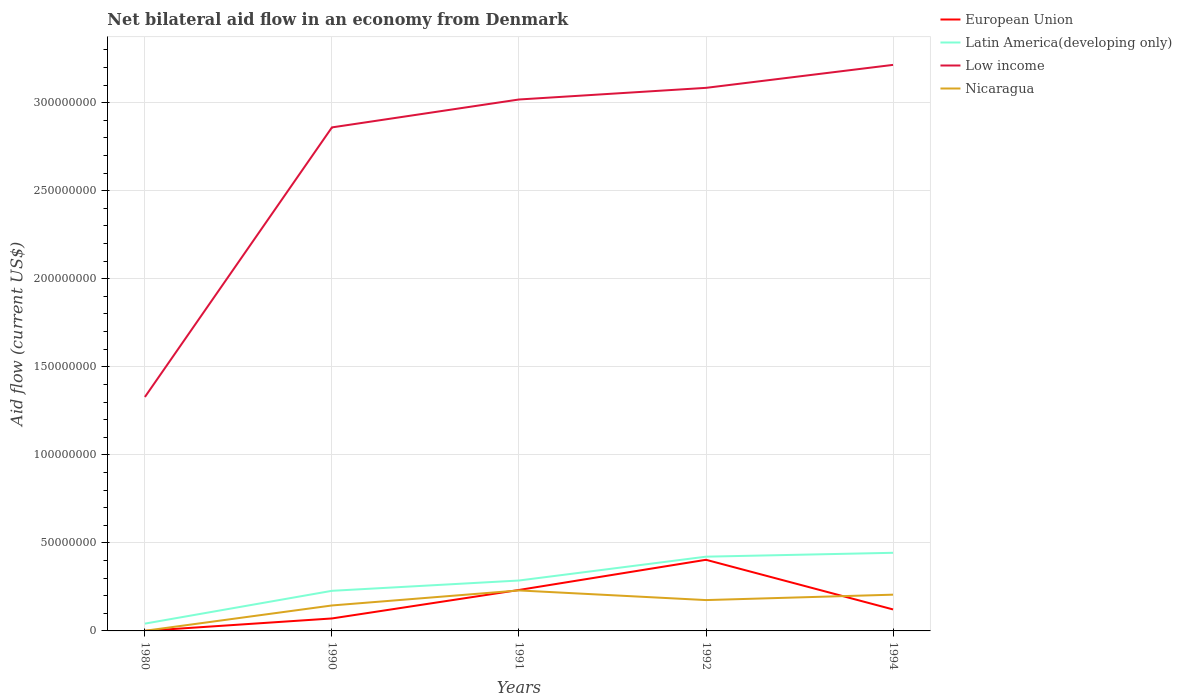Does the line corresponding to Latin America(developing only) intersect with the line corresponding to Low income?
Offer a very short reply. No. Is the number of lines equal to the number of legend labels?
Provide a short and direct response. Yes. Across all years, what is the maximum net bilateral aid flow in European Union?
Offer a very short reply. 2.00e+04. In which year was the net bilateral aid flow in Low income maximum?
Your answer should be very brief. 1980. What is the total net bilateral aid flow in European Union in the graph?
Provide a short and direct response. -4.04e+07. What is the difference between the highest and the second highest net bilateral aid flow in European Union?
Keep it short and to the point. 4.04e+07. How many years are there in the graph?
Provide a succinct answer. 5. Does the graph contain grids?
Your answer should be compact. Yes. How many legend labels are there?
Make the answer very short. 4. What is the title of the graph?
Provide a succinct answer. Net bilateral aid flow in an economy from Denmark. Does "Europe(developing only)" appear as one of the legend labels in the graph?
Provide a short and direct response. No. What is the Aid flow (current US$) in Latin America(developing only) in 1980?
Provide a short and direct response. 4.14e+06. What is the Aid flow (current US$) of Low income in 1980?
Offer a very short reply. 1.33e+08. What is the Aid flow (current US$) in European Union in 1990?
Ensure brevity in your answer.  7.08e+06. What is the Aid flow (current US$) in Latin America(developing only) in 1990?
Provide a short and direct response. 2.28e+07. What is the Aid flow (current US$) in Low income in 1990?
Provide a succinct answer. 2.86e+08. What is the Aid flow (current US$) in Nicaragua in 1990?
Your answer should be very brief. 1.45e+07. What is the Aid flow (current US$) of European Union in 1991?
Offer a very short reply. 2.33e+07. What is the Aid flow (current US$) of Latin America(developing only) in 1991?
Your answer should be compact. 2.86e+07. What is the Aid flow (current US$) in Low income in 1991?
Your answer should be compact. 3.02e+08. What is the Aid flow (current US$) in Nicaragua in 1991?
Ensure brevity in your answer.  2.30e+07. What is the Aid flow (current US$) of European Union in 1992?
Make the answer very short. 4.04e+07. What is the Aid flow (current US$) in Latin America(developing only) in 1992?
Your response must be concise. 4.22e+07. What is the Aid flow (current US$) in Low income in 1992?
Offer a very short reply. 3.08e+08. What is the Aid flow (current US$) of Nicaragua in 1992?
Offer a terse response. 1.75e+07. What is the Aid flow (current US$) of European Union in 1994?
Keep it short and to the point. 1.22e+07. What is the Aid flow (current US$) in Latin America(developing only) in 1994?
Your answer should be very brief. 4.44e+07. What is the Aid flow (current US$) of Low income in 1994?
Your answer should be compact. 3.21e+08. What is the Aid flow (current US$) in Nicaragua in 1994?
Your answer should be compact. 2.06e+07. Across all years, what is the maximum Aid flow (current US$) in European Union?
Give a very brief answer. 4.04e+07. Across all years, what is the maximum Aid flow (current US$) in Latin America(developing only)?
Your answer should be very brief. 4.44e+07. Across all years, what is the maximum Aid flow (current US$) of Low income?
Keep it short and to the point. 3.21e+08. Across all years, what is the maximum Aid flow (current US$) of Nicaragua?
Offer a terse response. 2.30e+07. Across all years, what is the minimum Aid flow (current US$) of Latin America(developing only)?
Provide a succinct answer. 4.14e+06. Across all years, what is the minimum Aid flow (current US$) of Low income?
Keep it short and to the point. 1.33e+08. What is the total Aid flow (current US$) of European Union in the graph?
Ensure brevity in your answer.  8.30e+07. What is the total Aid flow (current US$) in Latin America(developing only) in the graph?
Provide a succinct answer. 1.42e+08. What is the total Aid flow (current US$) of Low income in the graph?
Offer a very short reply. 1.35e+09. What is the total Aid flow (current US$) of Nicaragua in the graph?
Keep it short and to the point. 7.56e+07. What is the difference between the Aid flow (current US$) in European Union in 1980 and that in 1990?
Your response must be concise. -7.06e+06. What is the difference between the Aid flow (current US$) in Latin America(developing only) in 1980 and that in 1990?
Offer a terse response. -1.86e+07. What is the difference between the Aid flow (current US$) in Low income in 1980 and that in 1990?
Offer a very short reply. -1.53e+08. What is the difference between the Aid flow (current US$) of Nicaragua in 1980 and that in 1990?
Provide a short and direct response. -1.44e+07. What is the difference between the Aid flow (current US$) of European Union in 1980 and that in 1991?
Offer a very short reply. -2.32e+07. What is the difference between the Aid flow (current US$) of Latin America(developing only) in 1980 and that in 1991?
Make the answer very short. -2.45e+07. What is the difference between the Aid flow (current US$) of Low income in 1980 and that in 1991?
Your answer should be compact. -1.69e+08. What is the difference between the Aid flow (current US$) in Nicaragua in 1980 and that in 1991?
Offer a very short reply. -2.29e+07. What is the difference between the Aid flow (current US$) of European Union in 1980 and that in 1992?
Give a very brief answer. -4.04e+07. What is the difference between the Aid flow (current US$) in Latin America(developing only) in 1980 and that in 1992?
Offer a very short reply. -3.80e+07. What is the difference between the Aid flow (current US$) of Low income in 1980 and that in 1992?
Give a very brief answer. -1.76e+08. What is the difference between the Aid flow (current US$) of Nicaragua in 1980 and that in 1992?
Provide a succinct answer. -1.74e+07. What is the difference between the Aid flow (current US$) of European Union in 1980 and that in 1994?
Offer a very short reply. -1.22e+07. What is the difference between the Aid flow (current US$) of Latin America(developing only) in 1980 and that in 1994?
Offer a terse response. -4.02e+07. What is the difference between the Aid flow (current US$) in Low income in 1980 and that in 1994?
Give a very brief answer. -1.89e+08. What is the difference between the Aid flow (current US$) in Nicaragua in 1980 and that in 1994?
Provide a succinct answer. -2.05e+07. What is the difference between the Aid flow (current US$) in European Union in 1990 and that in 1991?
Ensure brevity in your answer.  -1.62e+07. What is the difference between the Aid flow (current US$) of Latin America(developing only) in 1990 and that in 1991?
Keep it short and to the point. -5.85e+06. What is the difference between the Aid flow (current US$) in Low income in 1990 and that in 1991?
Provide a succinct answer. -1.58e+07. What is the difference between the Aid flow (current US$) in Nicaragua in 1990 and that in 1991?
Provide a short and direct response. -8.53e+06. What is the difference between the Aid flow (current US$) of European Union in 1990 and that in 1992?
Keep it short and to the point. -3.33e+07. What is the difference between the Aid flow (current US$) in Latin America(developing only) in 1990 and that in 1992?
Provide a succinct answer. -1.94e+07. What is the difference between the Aid flow (current US$) of Low income in 1990 and that in 1992?
Offer a very short reply. -2.25e+07. What is the difference between the Aid flow (current US$) in Nicaragua in 1990 and that in 1992?
Your answer should be very brief. -3.06e+06. What is the difference between the Aid flow (current US$) of European Union in 1990 and that in 1994?
Provide a succinct answer. -5.12e+06. What is the difference between the Aid flow (current US$) in Latin America(developing only) in 1990 and that in 1994?
Make the answer very short. -2.16e+07. What is the difference between the Aid flow (current US$) in Low income in 1990 and that in 1994?
Your answer should be compact. -3.55e+07. What is the difference between the Aid flow (current US$) of Nicaragua in 1990 and that in 1994?
Offer a terse response. -6.13e+06. What is the difference between the Aid flow (current US$) in European Union in 1991 and that in 1992?
Ensure brevity in your answer.  -1.71e+07. What is the difference between the Aid flow (current US$) in Latin America(developing only) in 1991 and that in 1992?
Your answer should be very brief. -1.35e+07. What is the difference between the Aid flow (current US$) of Low income in 1991 and that in 1992?
Ensure brevity in your answer.  -6.61e+06. What is the difference between the Aid flow (current US$) of Nicaragua in 1991 and that in 1992?
Your answer should be compact. 5.47e+06. What is the difference between the Aid flow (current US$) of European Union in 1991 and that in 1994?
Give a very brief answer. 1.11e+07. What is the difference between the Aid flow (current US$) of Latin America(developing only) in 1991 and that in 1994?
Give a very brief answer. -1.57e+07. What is the difference between the Aid flow (current US$) of Low income in 1991 and that in 1994?
Provide a short and direct response. -1.97e+07. What is the difference between the Aid flow (current US$) of Nicaragua in 1991 and that in 1994?
Offer a very short reply. 2.40e+06. What is the difference between the Aid flow (current US$) in European Union in 1992 and that in 1994?
Your answer should be very brief. 2.82e+07. What is the difference between the Aid flow (current US$) in Latin America(developing only) in 1992 and that in 1994?
Provide a succinct answer. -2.20e+06. What is the difference between the Aid flow (current US$) in Low income in 1992 and that in 1994?
Provide a short and direct response. -1.30e+07. What is the difference between the Aid flow (current US$) in Nicaragua in 1992 and that in 1994?
Offer a terse response. -3.07e+06. What is the difference between the Aid flow (current US$) of European Union in 1980 and the Aid flow (current US$) of Latin America(developing only) in 1990?
Offer a terse response. -2.28e+07. What is the difference between the Aid flow (current US$) of European Union in 1980 and the Aid flow (current US$) of Low income in 1990?
Provide a succinct answer. -2.86e+08. What is the difference between the Aid flow (current US$) in European Union in 1980 and the Aid flow (current US$) in Nicaragua in 1990?
Provide a succinct answer. -1.44e+07. What is the difference between the Aid flow (current US$) in Latin America(developing only) in 1980 and the Aid flow (current US$) in Low income in 1990?
Make the answer very short. -2.82e+08. What is the difference between the Aid flow (current US$) in Latin America(developing only) in 1980 and the Aid flow (current US$) in Nicaragua in 1990?
Ensure brevity in your answer.  -1.03e+07. What is the difference between the Aid flow (current US$) in Low income in 1980 and the Aid flow (current US$) in Nicaragua in 1990?
Ensure brevity in your answer.  1.18e+08. What is the difference between the Aid flow (current US$) of European Union in 1980 and the Aid flow (current US$) of Latin America(developing only) in 1991?
Your answer should be very brief. -2.86e+07. What is the difference between the Aid flow (current US$) in European Union in 1980 and the Aid flow (current US$) in Low income in 1991?
Give a very brief answer. -3.02e+08. What is the difference between the Aid flow (current US$) of European Union in 1980 and the Aid flow (current US$) of Nicaragua in 1991?
Make the answer very short. -2.30e+07. What is the difference between the Aid flow (current US$) of Latin America(developing only) in 1980 and the Aid flow (current US$) of Low income in 1991?
Offer a terse response. -2.98e+08. What is the difference between the Aid flow (current US$) in Latin America(developing only) in 1980 and the Aid flow (current US$) in Nicaragua in 1991?
Offer a terse response. -1.88e+07. What is the difference between the Aid flow (current US$) of Low income in 1980 and the Aid flow (current US$) of Nicaragua in 1991?
Keep it short and to the point. 1.10e+08. What is the difference between the Aid flow (current US$) of European Union in 1980 and the Aid flow (current US$) of Latin America(developing only) in 1992?
Provide a short and direct response. -4.22e+07. What is the difference between the Aid flow (current US$) in European Union in 1980 and the Aid flow (current US$) in Low income in 1992?
Provide a short and direct response. -3.08e+08. What is the difference between the Aid flow (current US$) in European Union in 1980 and the Aid flow (current US$) in Nicaragua in 1992?
Provide a succinct answer. -1.75e+07. What is the difference between the Aid flow (current US$) of Latin America(developing only) in 1980 and the Aid flow (current US$) of Low income in 1992?
Offer a very short reply. -3.04e+08. What is the difference between the Aid flow (current US$) in Latin America(developing only) in 1980 and the Aid flow (current US$) in Nicaragua in 1992?
Your answer should be compact. -1.34e+07. What is the difference between the Aid flow (current US$) in Low income in 1980 and the Aid flow (current US$) in Nicaragua in 1992?
Give a very brief answer. 1.15e+08. What is the difference between the Aid flow (current US$) in European Union in 1980 and the Aid flow (current US$) in Latin America(developing only) in 1994?
Give a very brief answer. -4.44e+07. What is the difference between the Aid flow (current US$) in European Union in 1980 and the Aid flow (current US$) in Low income in 1994?
Provide a short and direct response. -3.21e+08. What is the difference between the Aid flow (current US$) of European Union in 1980 and the Aid flow (current US$) of Nicaragua in 1994?
Make the answer very short. -2.06e+07. What is the difference between the Aid flow (current US$) in Latin America(developing only) in 1980 and the Aid flow (current US$) in Low income in 1994?
Your answer should be very brief. -3.17e+08. What is the difference between the Aid flow (current US$) in Latin America(developing only) in 1980 and the Aid flow (current US$) in Nicaragua in 1994?
Provide a short and direct response. -1.64e+07. What is the difference between the Aid flow (current US$) in Low income in 1980 and the Aid flow (current US$) in Nicaragua in 1994?
Your response must be concise. 1.12e+08. What is the difference between the Aid flow (current US$) of European Union in 1990 and the Aid flow (current US$) of Latin America(developing only) in 1991?
Your response must be concise. -2.16e+07. What is the difference between the Aid flow (current US$) of European Union in 1990 and the Aid flow (current US$) of Low income in 1991?
Your answer should be very brief. -2.95e+08. What is the difference between the Aid flow (current US$) of European Union in 1990 and the Aid flow (current US$) of Nicaragua in 1991?
Keep it short and to the point. -1.59e+07. What is the difference between the Aid flow (current US$) of Latin America(developing only) in 1990 and the Aid flow (current US$) of Low income in 1991?
Make the answer very short. -2.79e+08. What is the difference between the Aid flow (current US$) in Low income in 1990 and the Aid flow (current US$) in Nicaragua in 1991?
Provide a succinct answer. 2.63e+08. What is the difference between the Aid flow (current US$) in European Union in 1990 and the Aid flow (current US$) in Latin America(developing only) in 1992?
Give a very brief answer. -3.51e+07. What is the difference between the Aid flow (current US$) of European Union in 1990 and the Aid flow (current US$) of Low income in 1992?
Make the answer very short. -3.01e+08. What is the difference between the Aid flow (current US$) of European Union in 1990 and the Aid flow (current US$) of Nicaragua in 1992?
Provide a succinct answer. -1.04e+07. What is the difference between the Aid flow (current US$) of Latin America(developing only) in 1990 and the Aid flow (current US$) of Low income in 1992?
Offer a terse response. -2.86e+08. What is the difference between the Aid flow (current US$) in Latin America(developing only) in 1990 and the Aid flow (current US$) in Nicaragua in 1992?
Your answer should be very brief. 5.26e+06. What is the difference between the Aid flow (current US$) of Low income in 1990 and the Aid flow (current US$) of Nicaragua in 1992?
Ensure brevity in your answer.  2.68e+08. What is the difference between the Aid flow (current US$) in European Union in 1990 and the Aid flow (current US$) in Latin America(developing only) in 1994?
Provide a succinct answer. -3.73e+07. What is the difference between the Aid flow (current US$) of European Union in 1990 and the Aid flow (current US$) of Low income in 1994?
Provide a succinct answer. -3.14e+08. What is the difference between the Aid flow (current US$) of European Union in 1990 and the Aid flow (current US$) of Nicaragua in 1994?
Offer a very short reply. -1.35e+07. What is the difference between the Aid flow (current US$) of Latin America(developing only) in 1990 and the Aid flow (current US$) of Low income in 1994?
Offer a very short reply. -2.99e+08. What is the difference between the Aid flow (current US$) of Latin America(developing only) in 1990 and the Aid flow (current US$) of Nicaragua in 1994?
Your response must be concise. 2.19e+06. What is the difference between the Aid flow (current US$) of Low income in 1990 and the Aid flow (current US$) of Nicaragua in 1994?
Give a very brief answer. 2.65e+08. What is the difference between the Aid flow (current US$) in European Union in 1991 and the Aid flow (current US$) in Latin America(developing only) in 1992?
Provide a succinct answer. -1.89e+07. What is the difference between the Aid flow (current US$) of European Union in 1991 and the Aid flow (current US$) of Low income in 1992?
Provide a succinct answer. -2.85e+08. What is the difference between the Aid flow (current US$) in European Union in 1991 and the Aid flow (current US$) in Nicaragua in 1992?
Your answer should be very brief. 5.74e+06. What is the difference between the Aid flow (current US$) of Latin America(developing only) in 1991 and the Aid flow (current US$) of Low income in 1992?
Give a very brief answer. -2.80e+08. What is the difference between the Aid flow (current US$) of Latin America(developing only) in 1991 and the Aid flow (current US$) of Nicaragua in 1992?
Offer a terse response. 1.11e+07. What is the difference between the Aid flow (current US$) in Low income in 1991 and the Aid flow (current US$) in Nicaragua in 1992?
Give a very brief answer. 2.84e+08. What is the difference between the Aid flow (current US$) of European Union in 1991 and the Aid flow (current US$) of Latin America(developing only) in 1994?
Make the answer very short. -2.11e+07. What is the difference between the Aid flow (current US$) in European Union in 1991 and the Aid flow (current US$) in Low income in 1994?
Your response must be concise. -2.98e+08. What is the difference between the Aid flow (current US$) of European Union in 1991 and the Aid flow (current US$) of Nicaragua in 1994?
Your answer should be very brief. 2.67e+06. What is the difference between the Aid flow (current US$) in Latin America(developing only) in 1991 and the Aid flow (current US$) in Low income in 1994?
Provide a succinct answer. -2.93e+08. What is the difference between the Aid flow (current US$) of Latin America(developing only) in 1991 and the Aid flow (current US$) of Nicaragua in 1994?
Make the answer very short. 8.04e+06. What is the difference between the Aid flow (current US$) of Low income in 1991 and the Aid flow (current US$) of Nicaragua in 1994?
Give a very brief answer. 2.81e+08. What is the difference between the Aid flow (current US$) of European Union in 1992 and the Aid flow (current US$) of Latin America(developing only) in 1994?
Your response must be concise. -3.97e+06. What is the difference between the Aid flow (current US$) in European Union in 1992 and the Aid flow (current US$) in Low income in 1994?
Your answer should be very brief. -2.81e+08. What is the difference between the Aid flow (current US$) in European Union in 1992 and the Aid flow (current US$) in Nicaragua in 1994?
Keep it short and to the point. 1.98e+07. What is the difference between the Aid flow (current US$) of Latin America(developing only) in 1992 and the Aid flow (current US$) of Low income in 1994?
Provide a short and direct response. -2.79e+08. What is the difference between the Aid flow (current US$) in Latin America(developing only) in 1992 and the Aid flow (current US$) in Nicaragua in 1994?
Keep it short and to the point. 2.16e+07. What is the difference between the Aid flow (current US$) of Low income in 1992 and the Aid flow (current US$) of Nicaragua in 1994?
Provide a succinct answer. 2.88e+08. What is the average Aid flow (current US$) in European Union per year?
Offer a terse response. 1.66e+07. What is the average Aid flow (current US$) in Latin America(developing only) per year?
Give a very brief answer. 2.84e+07. What is the average Aid flow (current US$) of Low income per year?
Give a very brief answer. 2.70e+08. What is the average Aid flow (current US$) of Nicaragua per year?
Keep it short and to the point. 1.51e+07. In the year 1980, what is the difference between the Aid flow (current US$) in European Union and Aid flow (current US$) in Latin America(developing only)?
Provide a short and direct response. -4.12e+06. In the year 1980, what is the difference between the Aid flow (current US$) of European Union and Aid flow (current US$) of Low income?
Your answer should be very brief. -1.33e+08. In the year 1980, what is the difference between the Aid flow (current US$) in European Union and Aid flow (current US$) in Nicaragua?
Provide a short and direct response. -6.00e+04. In the year 1980, what is the difference between the Aid flow (current US$) of Latin America(developing only) and Aid flow (current US$) of Low income?
Offer a terse response. -1.29e+08. In the year 1980, what is the difference between the Aid flow (current US$) of Latin America(developing only) and Aid flow (current US$) of Nicaragua?
Your response must be concise. 4.06e+06. In the year 1980, what is the difference between the Aid flow (current US$) in Low income and Aid flow (current US$) in Nicaragua?
Your answer should be very brief. 1.33e+08. In the year 1990, what is the difference between the Aid flow (current US$) of European Union and Aid flow (current US$) of Latin America(developing only)?
Provide a succinct answer. -1.57e+07. In the year 1990, what is the difference between the Aid flow (current US$) in European Union and Aid flow (current US$) in Low income?
Keep it short and to the point. -2.79e+08. In the year 1990, what is the difference between the Aid flow (current US$) of European Union and Aid flow (current US$) of Nicaragua?
Your answer should be very brief. -7.38e+06. In the year 1990, what is the difference between the Aid flow (current US$) of Latin America(developing only) and Aid flow (current US$) of Low income?
Offer a terse response. -2.63e+08. In the year 1990, what is the difference between the Aid flow (current US$) in Latin America(developing only) and Aid flow (current US$) in Nicaragua?
Provide a succinct answer. 8.32e+06. In the year 1990, what is the difference between the Aid flow (current US$) in Low income and Aid flow (current US$) in Nicaragua?
Your answer should be compact. 2.72e+08. In the year 1991, what is the difference between the Aid flow (current US$) in European Union and Aid flow (current US$) in Latin America(developing only)?
Offer a terse response. -5.37e+06. In the year 1991, what is the difference between the Aid flow (current US$) of European Union and Aid flow (current US$) of Low income?
Offer a terse response. -2.79e+08. In the year 1991, what is the difference between the Aid flow (current US$) of European Union and Aid flow (current US$) of Nicaragua?
Ensure brevity in your answer.  2.70e+05. In the year 1991, what is the difference between the Aid flow (current US$) of Latin America(developing only) and Aid flow (current US$) of Low income?
Offer a very short reply. -2.73e+08. In the year 1991, what is the difference between the Aid flow (current US$) in Latin America(developing only) and Aid flow (current US$) in Nicaragua?
Provide a short and direct response. 5.64e+06. In the year 1991, what is the difference between the Aid flow (current US$) in Low income and Aid flow (current US$) in Nicaragua?
Offer a terse response. 2.79e+08. In the year 1992, what is the difference between the Aid flow (current US$) in European Union and Aid flow (current US$) in Latin America(developing only)?
Offer a very short reply. -1.77e+06. In the year 1992, what is the difference between the Aid flow (current US$) in European Union and Aid flow (current US$) in Low income?
Give a very brief answer. -2.68e+08. In the year 1992, what is the difference between the Aid flow (current US$) of European Union and Aid flow (current US$) of Nicaragua?
Make the answer very short. 2.29e+07. In the year 1992, what is the difference between the Aid flow (current US$) in Latin America(developing only) and Aid flow (current US$) in Low income?
Your answer should be very brief. -2.66e+08. In the year 1992, what is the difference between the Aid flow (current US$) in Latin America(developing only) and Aid flow (current US$) in Nicaragua?
Make the answer very short. 2.46e+07. In the year 1992, what is the difference between the Aid flow (current US$) in Low income and Aid flow (current US$) in Nicaragua?
Your response must be concise. 2.91e+08. In the year 1994, what is the difference between the Aid flow (current US$) in European Union and Aid flow (current US$) in Latin America(developing only)?
Keep it short and to the point. -3.22e+07. In the year 1994, what is the difference between the Aid flow (current US$) of European Union and Aid flow (current US$) of Low income?
Provide a short and direct response. -3.09e+08. In the year 1994, what is the difference between the Aid flow (current US$) of European Union and Aid flow (current US$) of Nicaragua?
Offer a terse response. -8.39e+06. In the year 1994, what is the difference between the Aid flow (current US$) of Latin America(developing only) and Aid flow (current US$) of Low income?
Provide a short and direct response. -2.77e+08. In the year 1994, what is the difference between the Aid flow (current US$) of Latin America(developing only) and Aid flow (current US$) of Nicaragua?
Give a very brief answer. 2.38e+07. In the year 1994, what is the difference between the Aid flow (current US$) of Low income and Aid flow (current US$) of Nicaragua?
Your answer should be compact. 3.01e+08. What is the ratio of the Aid flow (current US$) of European Union in 1980 to that in 1990?
Your answer should be compact. 0. What is the ratio of the Aid flow (current US$) of Latin America(developing only) in 1980 to that in 1990?
Your response must be concise. 0.18. What is the ratio of the Aid flow (current US$) of Low income in 1980 to that in 1990?
Ensure brevity in your answer.  0.46. What is the ratio of the Aid flow (current US$) in Nicaragua in 1980 to that in 1990?
Make the answer very short. 0.01. What is the ratio of the Aid flow (current US$) of European Union in 1980 to that in 1991?
Your answer should be very brief. 0. What is the ratio of the Aid flow (current US$) in Latin America(developing only) in 1980 to that in 1991?
Your answer should be very brief. 0.14. What is the ratio of the Aid flow (current US$) in Low income in 1980 to that in 1991?
Provide a short and direct response. 0.44. What is the ratio of the Aid flow (current US$) in Nicaragua in 1980 to that in 1991?
Give a very brief answer. 0. What is the ratio of the Aid flow (current US$) of European Union in 1980 to that in 1992?
Your response must be concise. 0. What is the ratio of the Aid flow (current US$) in Latin America(developing only) in 1980 to that in 1992?
Your answer should be very brief. 0.1. What is the ratio of the Aid flow (current US$) of Low income in 1980 to that in 1992?
Keep it short and to the point. 0.43. What is the ratio of the Aid flow (current US$) in Nicaragua in 1980 to that in 1992?
Keep it short and to the point. 0. What is the ratio of the Aid flow (current US$) of European Union in 1980 to that in 1994?
Your response must be concise. 0. What is the ratio of the Aid flow (current US$) of Latin America(developing only) in 1980 to that in 1994?
Your answer should be compact. 0.09. What is the ratio of the Aid flow (current US$) of Low income in 1980 to that in 1994?
Offer a terse response. 0.41. What is the ratio of the Aid flow (current US$) of Nicaragua in 1980 to that in 1994?
Give a very brief answer. 0. What is the ratio of the Aid flow (current US$) in European Union in 1990 to that in 1991?
Your response must be concise. 0.3. What is the ratio of the Aid flow (current US$) in Latin America(developing only) in 1990 to that in 1991?
Offer a terse response. 0.8. What is the ratio of the Aid flow (current US$) in Low income in 1990 to that in 1991?
Keep it short and to the point. 0.95. What is the ratio of the Aid flow (current US$) in Nicaragua in 1990 to that in 1991?
Your answer should be very brief. 0.63. What is the ratio of the Aid flow (current US$) in European Union in 1990 to that in 1992?
Provide a short and direct response. 0.18. What is the ratio of the Aid flow (current US$) in Latin America(developing only) in 1990 to that in 1992?
Your answer should be very brief. 0.54. What is the ratio of the Aid flow (current US$) of Low income in 1990 to that in 1992?
Give a very brief answer. 0.93. What is the ratio of the Aid flow (current US$) in Nicaragua in 1990 to that in 1992?
Keep it short and to the point. 0.83. What is the ratio of the Aid flow (current US$) of European Union in 1990 to that in 1994?
Provide a short and direct response. 0.58. What is the ratio of the Aid flow (current US$) in Latin America(developing only) in 1990 to that in 1994?
Keep it short and to the point. 0.51. What is the ratio of the Aid flow (current US$) of Low income in 1990 to that in 1994?
Ensure brevity in your answer.  0.89. What is the ratio of the Aid flow (current US$) in Nicaragua in 1990 to that in 1994?
Offer a terse response. 0.7. What is the ratio of the Aid flow (current US$) of European Union in 1991 to that in 1992?
Keep it short and to the point. 0.58. What is the ratio of the Aid flow (current US$) in Latin America(developing only) in 1991 to that in 1992?
Provide a short and direct response. 0.68. What is the ratio of the Aid flow (current US$) of Low income in 1991 to that in 1992?
Your answer should be compact. 0.98. What is the ratio of the Aid flow (current US$) of Nicaragua in 1991 to that in 1992?
Make the answer very short. 1.31. What is the ratio of the Aid flow (current US$) of European Union in 1991 to that in 1994?
Offer a terse response. 1.91. What is the ratio of the Aid flow (current US$) of Latin America(developing only) in 1991 to that in 1994?
Your answer should be very brief. 0.65. What is the ratio of the Aid flow (current US$) in Low income in 1991 to that in 1994?
Offer a very short reply. 0.94. What is the ratio of the Aid flow (current US$) of Nicaragua in 1991 to that in 1994?
Offer a very short reply. 1.12. What is the ratio of the Aid flow (current US$) in European Union in 1992 to that in 1994?
Offer a very short reply. 3.31. What is the ratio of the Aid flow (current US$) in Latin America(developing only) in 1992 to that in 1994?
Ensure brevity in your answer.  0.95. What is the ratio of the Aid flow (current US$) of Low income in 1992 to that in 1994?
Provide a short and direct response. 0.96. What is the ratio of the Aid flow (current US$) in Nicaragua in 1992 to that in 1994?
Provide a short and direct response. 0.85. What is the difference between the highest and the second highest Aid flow (current US$) in European Union?
Make the answer very short. 1.71e+07. What is the difference between the highest and the second highest Aid flow (current US$) of Latin America(developing only)?
Provide a short and direct response. 2.20e+06. What is the difference between the highest and the second highest Aid flow (current US$) of Low income?
Give a very brief answer. 1.30e+07. What is the difference between the highest and the second highest Aid flow (current US$) of Nicaragua?
Offer a very short reply. 2.40e+06. What is the difference between the highest and the lowest Aid flow (current US$) in European Union?
Give a very brief answer. 4.04e+07. What is the difference between the highest and the lowest Aid flow (current US$) in Latin America(developing only)?
Offer a very short reply. 4.02e+07. What is the difference between the highest and the lowest Aid flow (current US$) of Low income?
Make the answer very short. 1.89e+08. What is the difference between the highest and the lowest Aid flow (current US$) of Nicaragua?
Offer a terse response. 2.29e+07. 